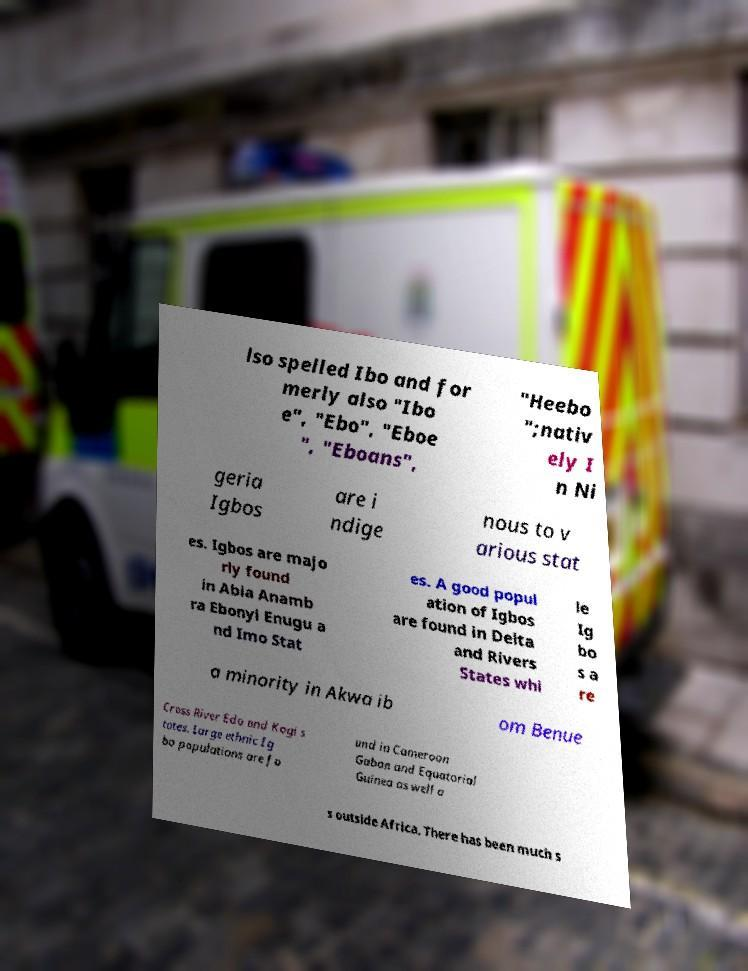Can you read and provide the text displayed in the image?This photo seems to have some interesting text. Can you extract and type it out for me? lso spelled Ibo and for merly also "Ibo e", "Ebo", "Eboe ", "Eboans", "Heebo ";nativ ely I n Ni geria Igbos are i ndige nous to v arious stat es. Igbos are majo rly found in Abia Anamb ra Ebonyi Enugu a nd Imo Stat es. A good popul ation of Igbos are found in Delta and Rivers States whi le Ig bo s a re a minority in Akwa ib om Benue Cross River Edo and Kogi s tates. Large ethnic Ig bo populations are fo und in Cameroon Gabon and Equatorial Guinea as well a s outside Africa. There has been much s 